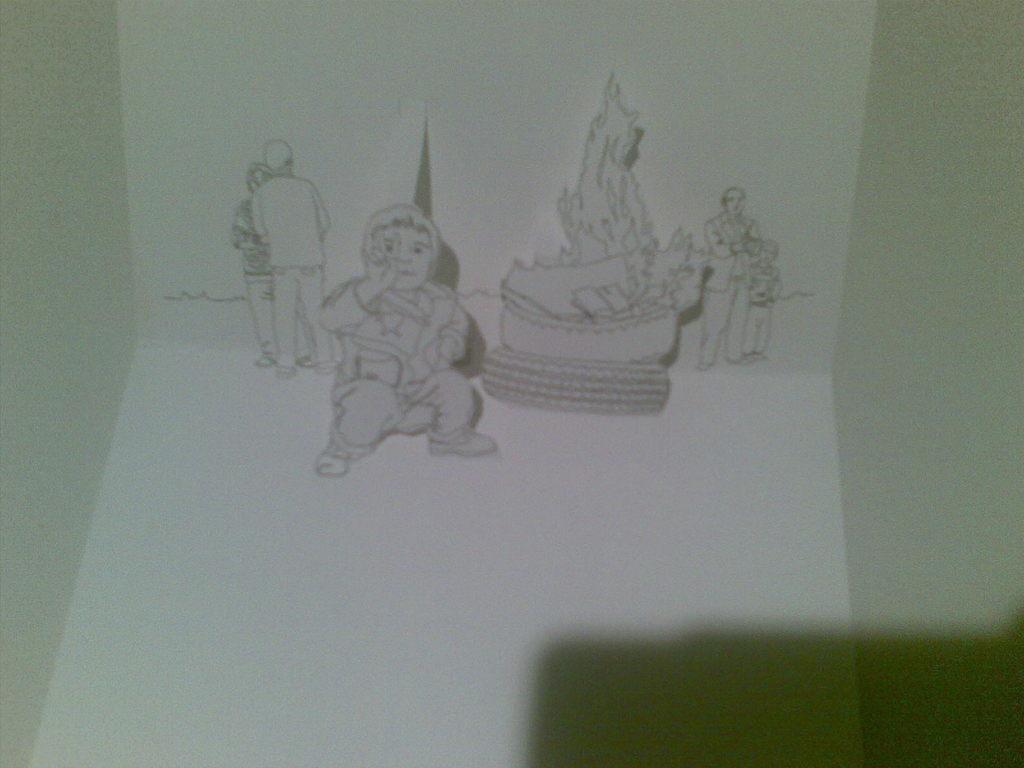What is depicted on the wall in the image? There is a sketch on the wall. What can be seen in the sketch? There are people in the sketch. What color is the wall in the image? The wall is white. What can be observed on the right side of the image? There is a shadow on the right side of the image. What type of popcorn is being served to the queen in the image? A: There is no popcorn or queen present in the image; it features a sketch on a white wall with people depicted. 